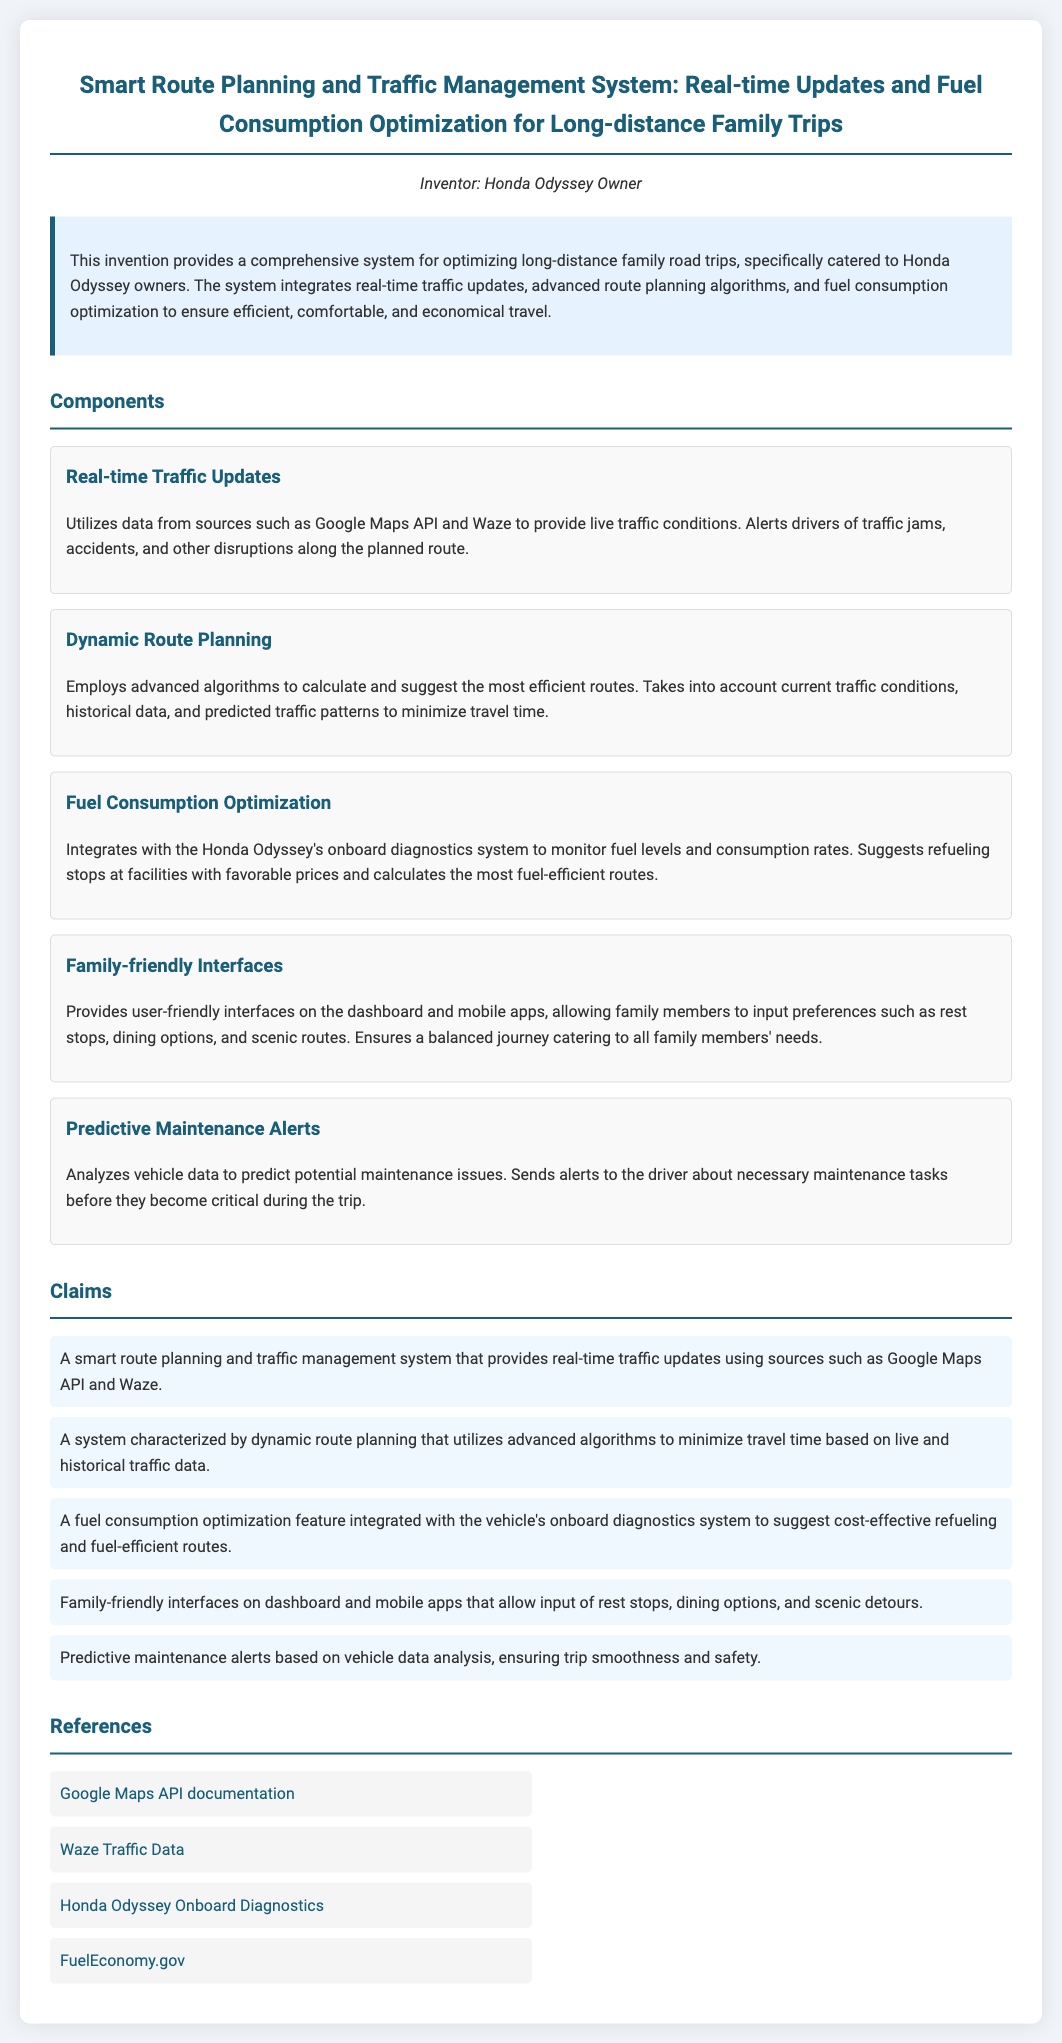What is the title of the patent? The title summarizes the focus of the invention as stated in the document.
Answer: Smart Route Planning and Traffic Management System: Real-time Updates and Fuel Consumption Optimization for Long-distance Family Trips Who is the inventor of the system? The inventor is mentioned at the beginning of the document.
Answer: Honda Odyssey Owner What component assesses live traffic conditions? This component utilizes specific data sources to provide real-time information on traffic.
Answer: Real-time Traffic Updates What is the primary function of the dynamic route planning component? This feature describes how it optimizes travel routes based on various traffic factors.
Answer: Minimize travel time Which mobile feature allows input of preferences for family stops? This specified component focuses on user interaction to enhance family travel experience.
Answer: Family-friendly Interfaces How many claims are listed in the document? The total number of claims is given in the section listing the system's features.
Answer: Five What feature predicts potential maintenance issues? This component informs the driver about necessary maintenance tasks.
Answer: Predictive Maintenance Alerts Which API is utilized for traffic updates? The document references a specific source for retrieving traffic conditions.
Answer: Google Maps API What kind of alerts does the fuel consumption optimization provide? This feature focuses on cost-effective refueling suggestions during trips.
Answer: Cost-effective refueling suggestions 